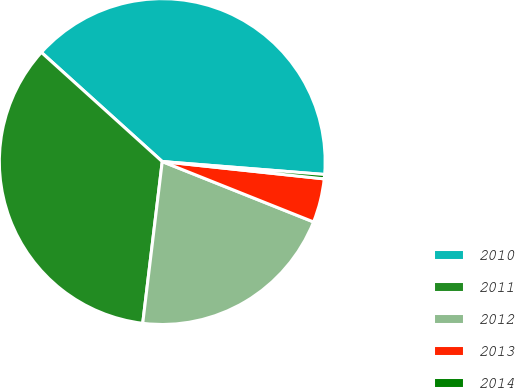<chart> <loc_0><loc_0><loc_500><loc_500><pie_chart><fcel>2010<fcel>2011<fcel>2012<fcel>2013<fcel>2014<nl><fcel>39.57%<fcel>34.78%<fcel>20.87%<fcel>4.35%<fcel>0.43%<nl></chart> 